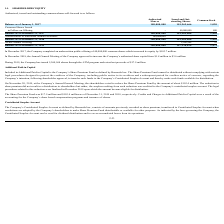According to Nordic American Tankers Limited's financial document, In December 2017, what was the increase in equity from the Company's underwritten public offering? According to the financial document, $103.7 million. The relevant text states: "00,000 common shares which increased its equity by $103.7 million...." Also, How many shares did the company issue in 2019 through the ATM program? According to the financial document, 5,260,968 shares. The relevant text states: "During 2019, the Company has issued 5,260,968 shares through the ATM program and raised net proceeds of $17.9 million...." Also, What are the respective number of authorised shares as of December 31, 2018 and 2019? The document shows two values: 360,000,000 and 360,000,000. From the document: "Balance as of December 31, 2018 360,000,000 141,969,666 1,420..." Also, can you calculate: What is the value of the number of shares issued by the company in 2017 as a percentage of its total issued and outstanding shares as at December 31, 2017? Based on the calculation: 40,000,000/141,969,666 , the result is 28.18 (percentage). This is based on the information: "Common Shares Issued in Follow-on Offering - 40,000,000 400 Balance as of December 31, 2017 180,000,000 141,969,666 1,420..." The key data points involved are: 141,969,666, 40,000,000. Also, can you calculate: What is the value of the number of issued shares in 2019 as a percentage of the company's total issued and outstanding shares as at December 31, 2019? Based on the calculation: 5,260,968/147,230,634 , the result is 3.57 (percentage). This is based on the information: "Balance as of December 31, 2019 360,000,000 147,230,634 1,472 At-the-Market Offering - 5,260,968 52..." The key data points involved are: 147,230,634, 5,260,968. Also, can you calculate: What is the average number of authorised shares as at December 31, 2018 and 2019? To answer this question, I need to perform calculations using the financial data. The calculation is: (360,000,000 + 360,000,000)/2 , which equals 360000000. This is based on the information: "Balance as of December 31, 2018 360,000,000 141,969,666 1,420..." 